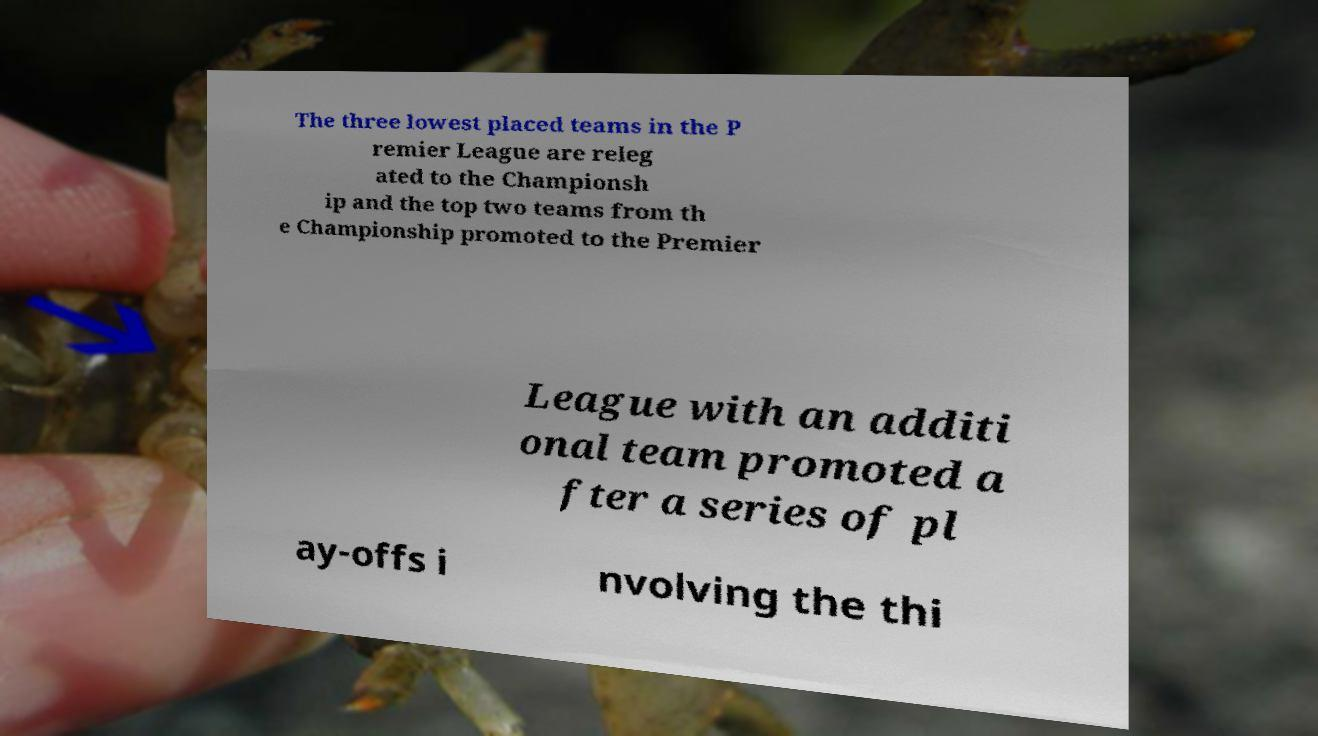For documentation purposes, I need the text within this image transcribed. Could you provide that? The three lowest placed teams in the P remier League are releg ated to the Championsh ip and the top two teams from th e Championship promoted to the Premier League with an additi onal team promoted a fter a series of pl ay-offs i nvolving the thi 